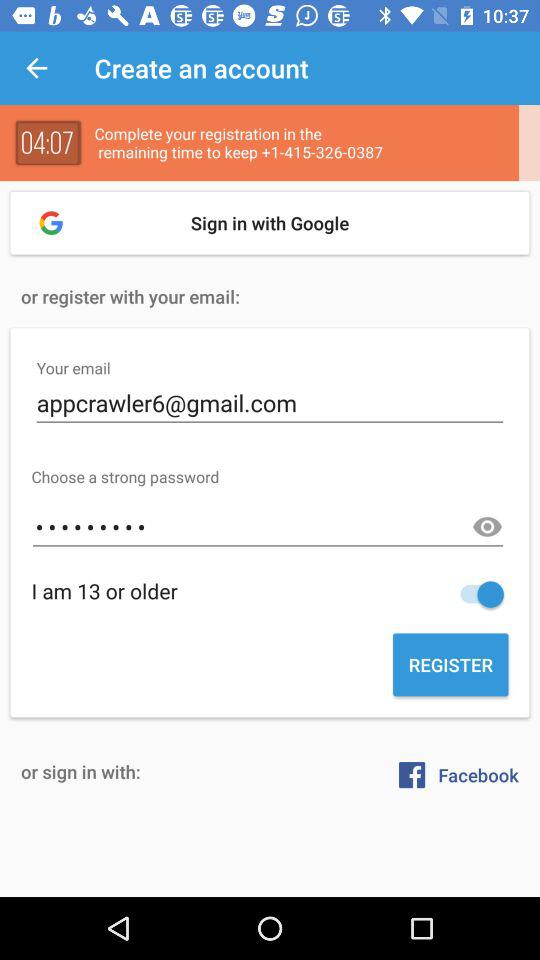What is the status of "I am 13 or older"? The status of "I am 13 or older" is "on". 